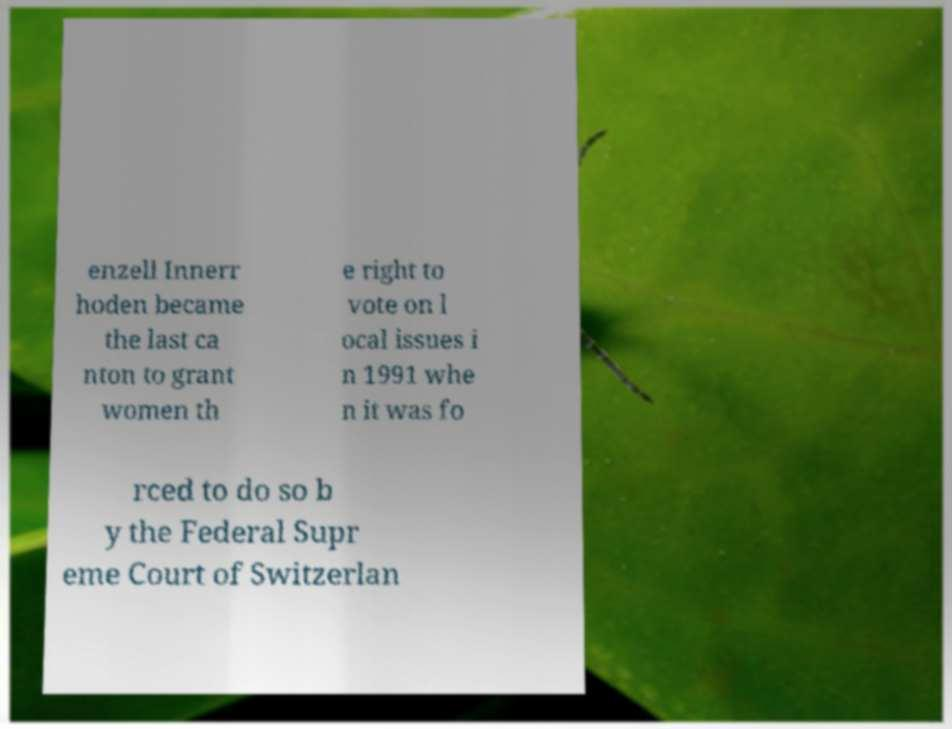For documentation purposes, I need the text within this image transcribed. Could you provide that? enzell Innerr hoden became the last ca nton to grant women th e right to vote on l ocal issues i n 1991 whe n it was fo rced to do so b y the Federal Supr eme Court of Switzerlan 